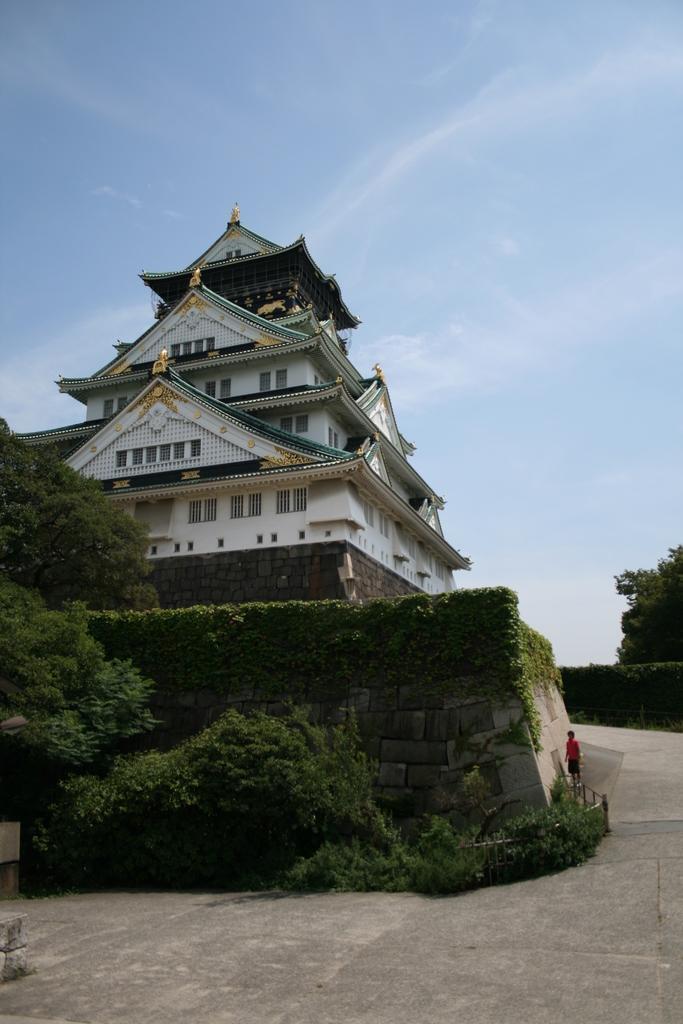Can you describe this image briefly? In this image we can see a building, in front of the building there is a tree and a wall with creeper plant and a person standing near the wall and the sky in the background. 